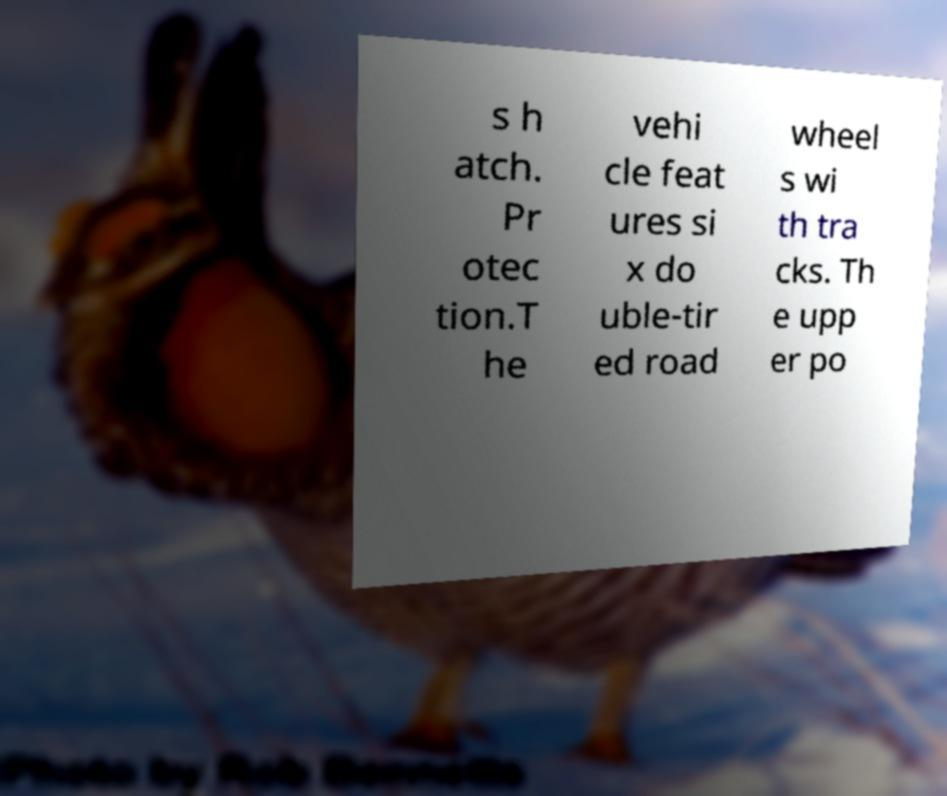There's text embedded in this image that I need extracted. Can you transcribe it verbatim? s h atch. Pr otec tion.T he vehi cle feat ures si x do uble-tir ed road wheel s wi th tra cks. Th e upp er po 